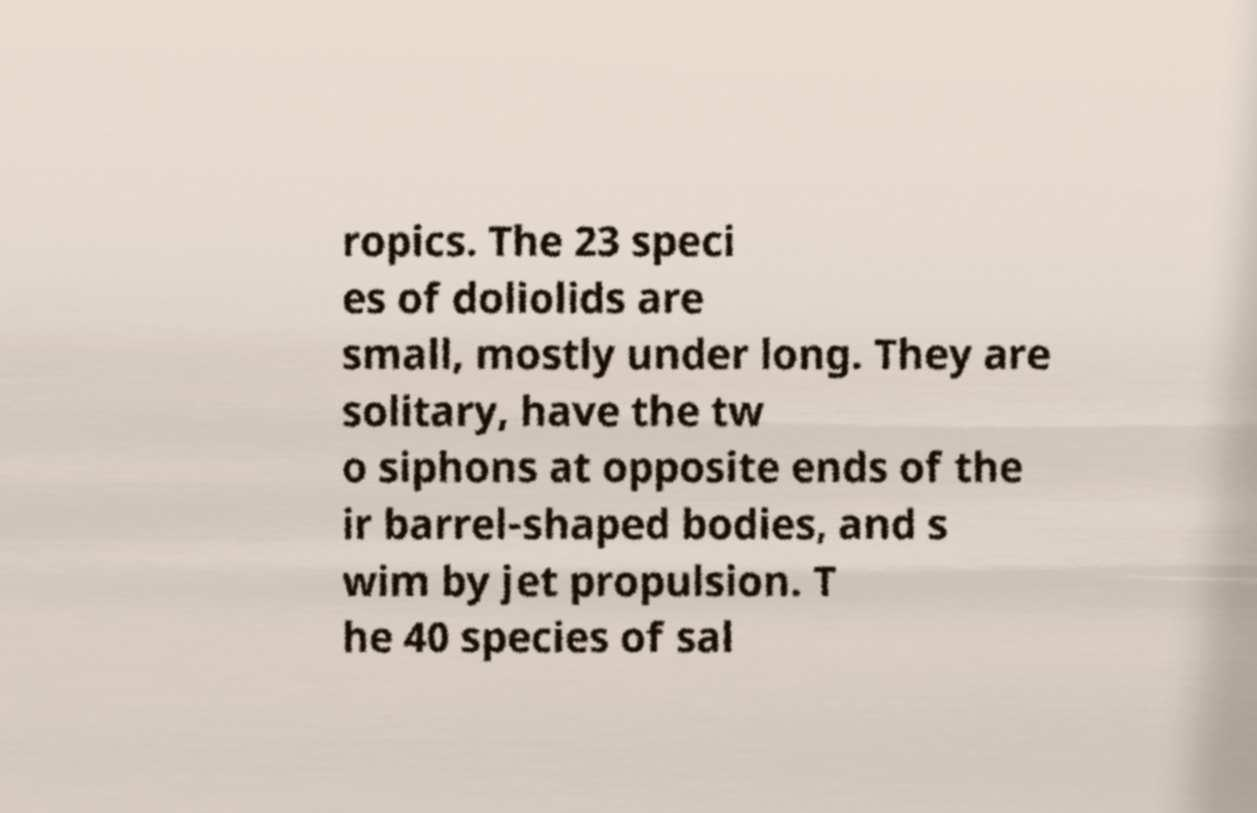Could you assist in decoding the text presented in this image and type it out clearly? ropics. The 23 speci es of doliolids are small, mostly under long. They are solitary, have the tw o siphons at opposite ends of the ir barrel-shaped bodies, and s wim by jet propulsion. T he 40 species of sal 